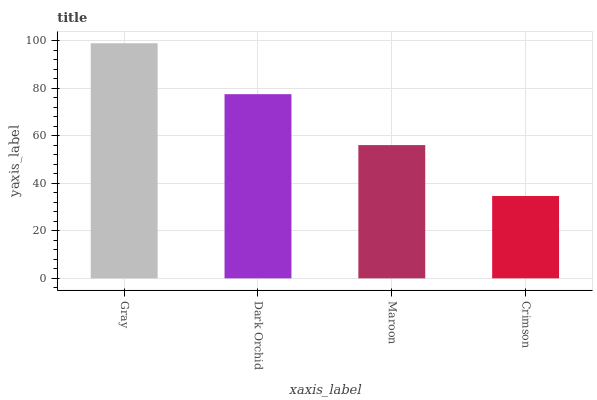Is Crimson the minimum?
Answer yes or no. Yes. Is Gray the maximum?
Answer yes or no. Yes. Is Dark Orchid the minimum?
Answer yes or no. No. Is Dark Orchid the maximum?
Answer yes or no. No. Is Gray greater than Dark Orchid?
Answer yes or no. Yes. Is Dark Orchid less than Gray?
Answer yes or no. Yes. Is Dark Orchid greater than Gray?
Answer yes or no. No. Is Gray less than Dark Orchid?
Answer yes or no. No. Is Dark Orchid the high median?
Answer yes or no. Yes. Is Maroon the low median?
Answer yes or no. Yes. Is Crimson the high median?
Answer yes or no. No. Is Gray the low median?
Answer yes or no. No. 